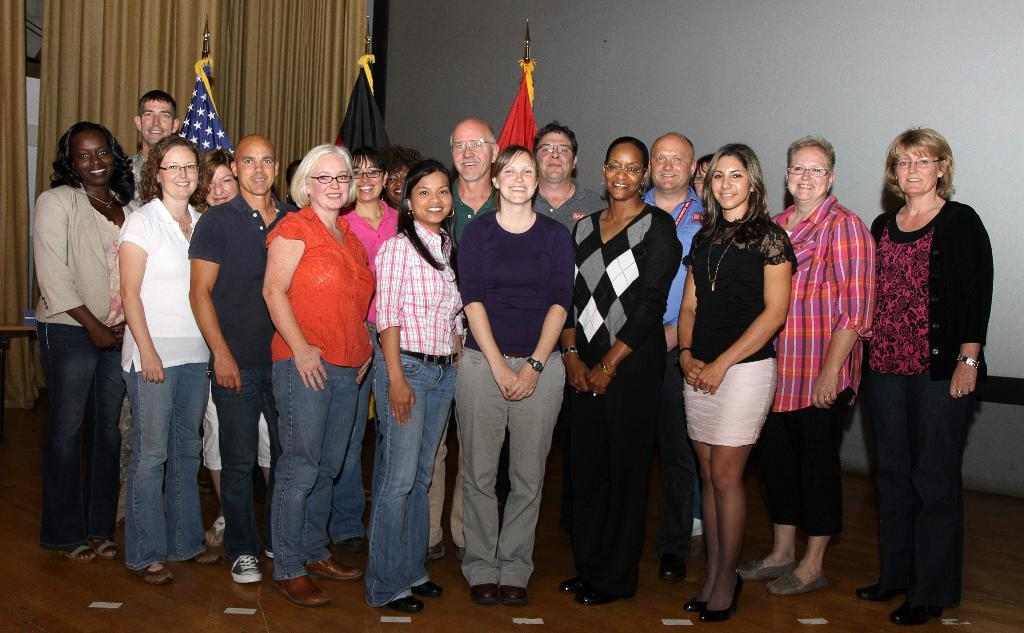How many people are the people in the image are positioned? The people in the image are standing and posing for a photo. What can be seen in the background of the image? There are three flags in the background of the image. Is there any object related to decoration or covering in the image? Yes, there is a curtain in the image. What type of tomatoes are being used to water the plants in the image? There are no tomatoes or plants visible in the image, and no watering is taking place. Can you tell me how many eggnogs are being served to the people in the image? There is no mention of eggnog or any beverages in the image. 